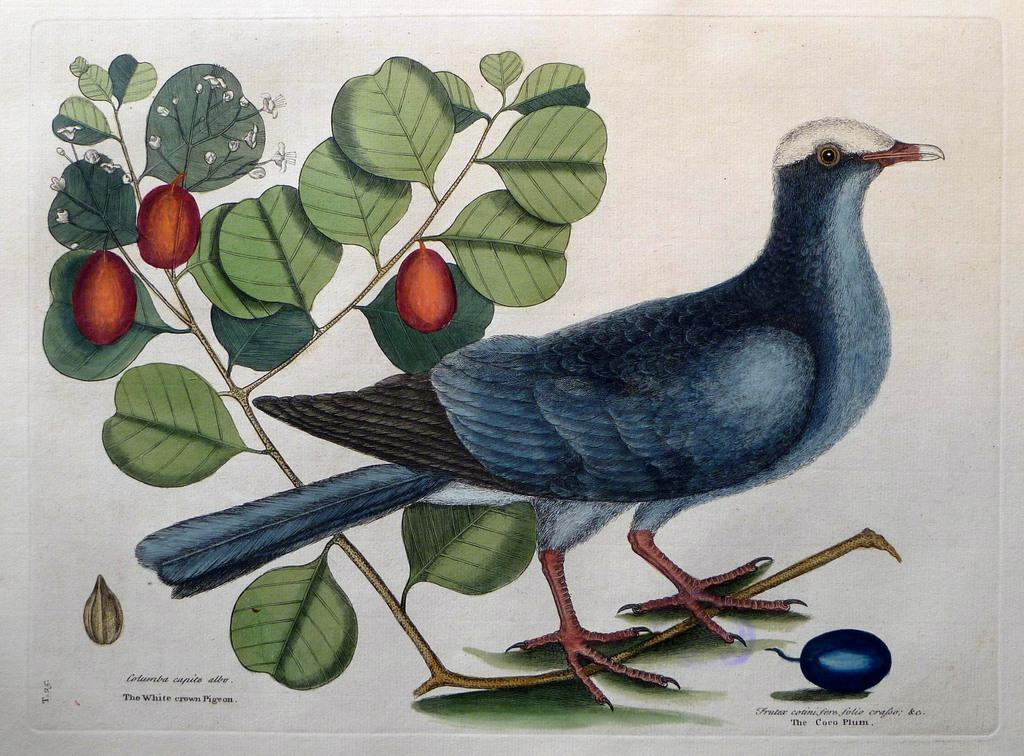What is the main subject of the image? The main subject of the image is a chart. What is depicted on the chart? The chart contains a drawing of a bird. What else can be seen in the image besides the chart? There are branches of a plant in the image. What is the state of the plant in the image? The branches have fruits on them. What type of screw is being used to hold the bird in place on the chart? There is no screw present in the image; the bird is drawn on the chart. 